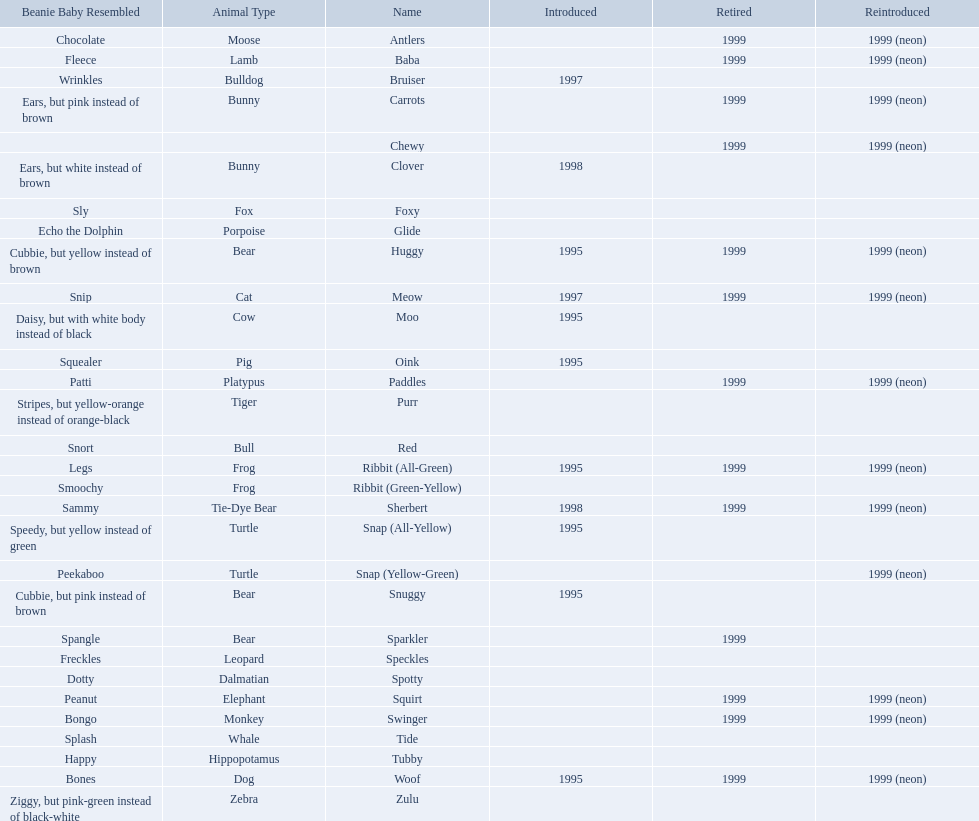What are all the different names of the pillow pals? Antlers, Baba, Bruiser, Carrots, Chewy, Clover, Foxy, Glide, Huggy, Meow, Moo, Oink, Paddles, Purr, Red, Ribbit (All-Green), Ribbit (Green-Yellow), Sherbert, Snap (All-Yellow), Snap (Yellow-Green), Snuggy, Sparkler, Speckles, Spotty, Squirt, Swinger, Tide, Tubby, Woof, Zulu. Which of these are a dalmatian? Spotty. Give me the full table as a dictionary. {'header': ['Beanie Baby Resembled', 'Animal Type', 'Name', 'Introduced', 'Retired', 'Reintroduced'], 'rows': [['Chocolate', 'Moose', 'Antlers', '', '1999', '1999 (neon)'], ['Fleece', 'Lamb', 'Baba', '', '1999', '1999 (neon)'], ['Wrinkles', 'Bulldog', 'Bruiser', '1997', '', ''], ['Ears, but pink instead of brown', 'Bunny', 'Carrots', '', '1999', '1999 (neon)'], ['', '', 'Chewy', '', '1999', '1999 (neon)'], ['Ears, but white instead of brown', 'Bunny', 'Clover', '1998', '', ''], ['Sly', 'Fox', 'Foxy', '', '', ''], ['Echo the Dolphin', 'Porpoise', 'Glide', '', '', ''], ['Cubbie, but yellow instead of brown', 'Bear', 'Huggy', '1995', '1999', '1999 (neon)'], ['Snip', 'Cat', 'Meow', '1997', '1999', '1999 (neon)'], ['Daisy, but with white body instead of black', 'Cow', 'Moo', '1995', '', ''], ['Squealer', 'Pig', 'Oink', '1995', '', ''], ['Patti', 'Platypus', 'Paddles', '', '1999', '1999 (neon)'], ['Stripes, but yellow-orange instead of orange-black', 'Tiger', 'Purr', '', '', ''], ['Snort', 'Bull', 'Red', '', '', ''], ['Legs', 'Frog', 'Ribbit (All-Green)', '1995', '1999', '1999 (neon)'], ['Smoochy', 'Frog', 'Ribbit (Green-Yellow)', '', '', ''], ['Sammy', 'Tie-Dye Bear', 'Sherbert', '1998', '1999', '1999 (neon)'], ['Speedy, but yellow instead of green', 'Turtle', 'Snap (All-Yellow)', '1995', '', ''], ['Peekaboo', 'Turtle', 'Snap (Yellow-Green)', '', '', '1999 (neon)'], ['Cubbie, but pink instead of brown', 'Bear', 'Snuggy', '1995', '', ''], ['Spangle', 'Bear', 'Sparkler', '', '1999', ''], ['Freckles', 'Leopard', 'Speckles', '', '', ''], ['Dotty', 'Dalmatian', 'Spotty', '', '', ''], ['Peanut', 'Elephant', 'Squirt', '', '1999', '1999 (neon)'], ['Bongo', 'Monkey', 'Swinger', '', '1999', '1999 (neon)'], ['Splash', 'Whale', 'Tide', '', '', ''], ['Happy', 'Hippopotamus', 'Tubby', '', '', ''], ['Bones', 'Dog', 'Woof', '1995', '1999', '1999 (neon)'], ['Ziggy, but pink-green instead of black-white', 'Zebra', 'Zulu', '', '', '']]} 